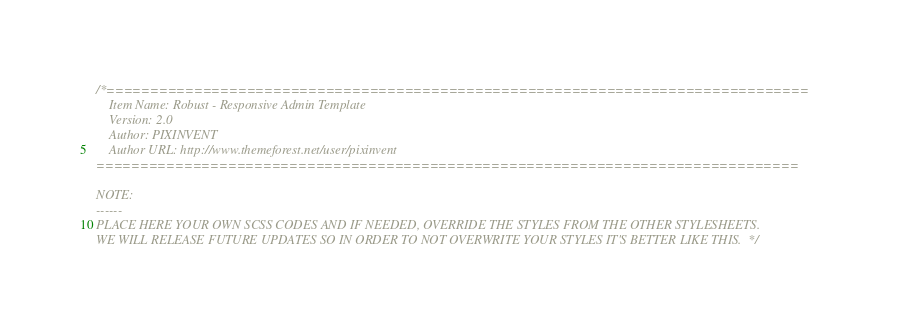Convert code to text. <code><loc_0><loc_0><loc_500><loc_500><_CSS_>/*================================================================================
	Item Name: Robust - Responsive Admin Template
	Version: 2.0
	Author: PIXINVENT
	Author URL: http://www.themeforest.net/user/pixinvent
================================================================================

NOTE:
------
PLACE HERE YOUR OWN SCSS CODES AND IF NEEDED, OVERRIDE THE STYLES FROM THE OTHER STYLESHEETS.
WE WILL RELEASE FUTURE UPDATES SO IN ORDER TO NOT OVERWRITE YOUR STYLES IT'S BETTER LIKE THIS.  */
</code> 